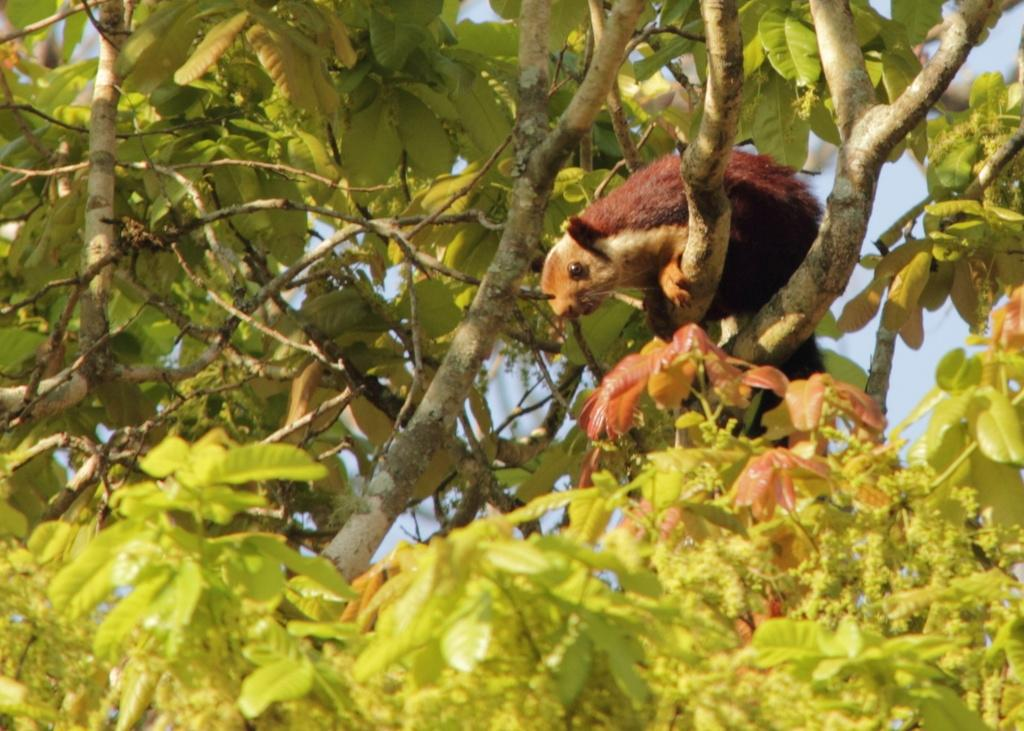What type of vegetation can be seen in the image? There are trees in the image. Can you describe the location of the animal in the image? The animal is on the branch of a tree on the right side of the image. How many sisters are present in the image? There are no sisters mentioned or depicted in the image. 